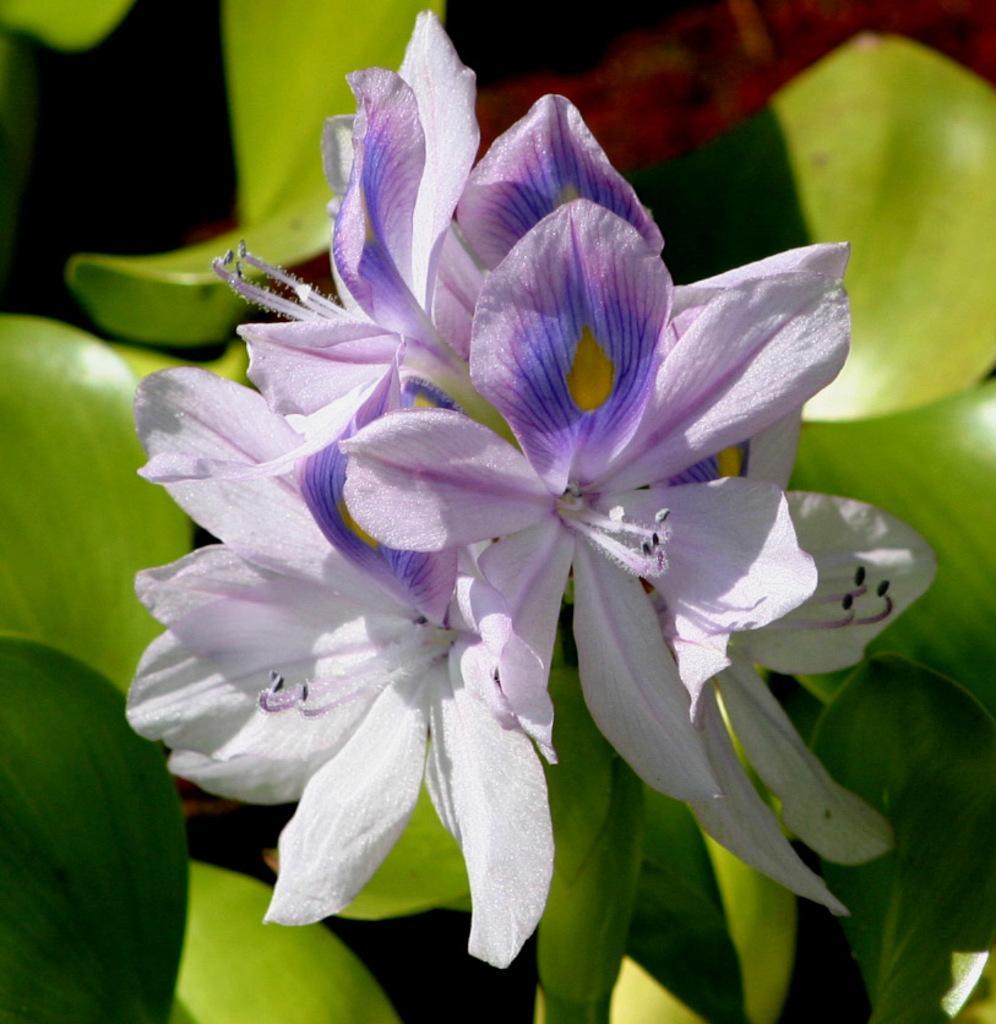Please provide a concise description of this image. In this image I see flowers which are of white and purple in color and I see the green leaves. 